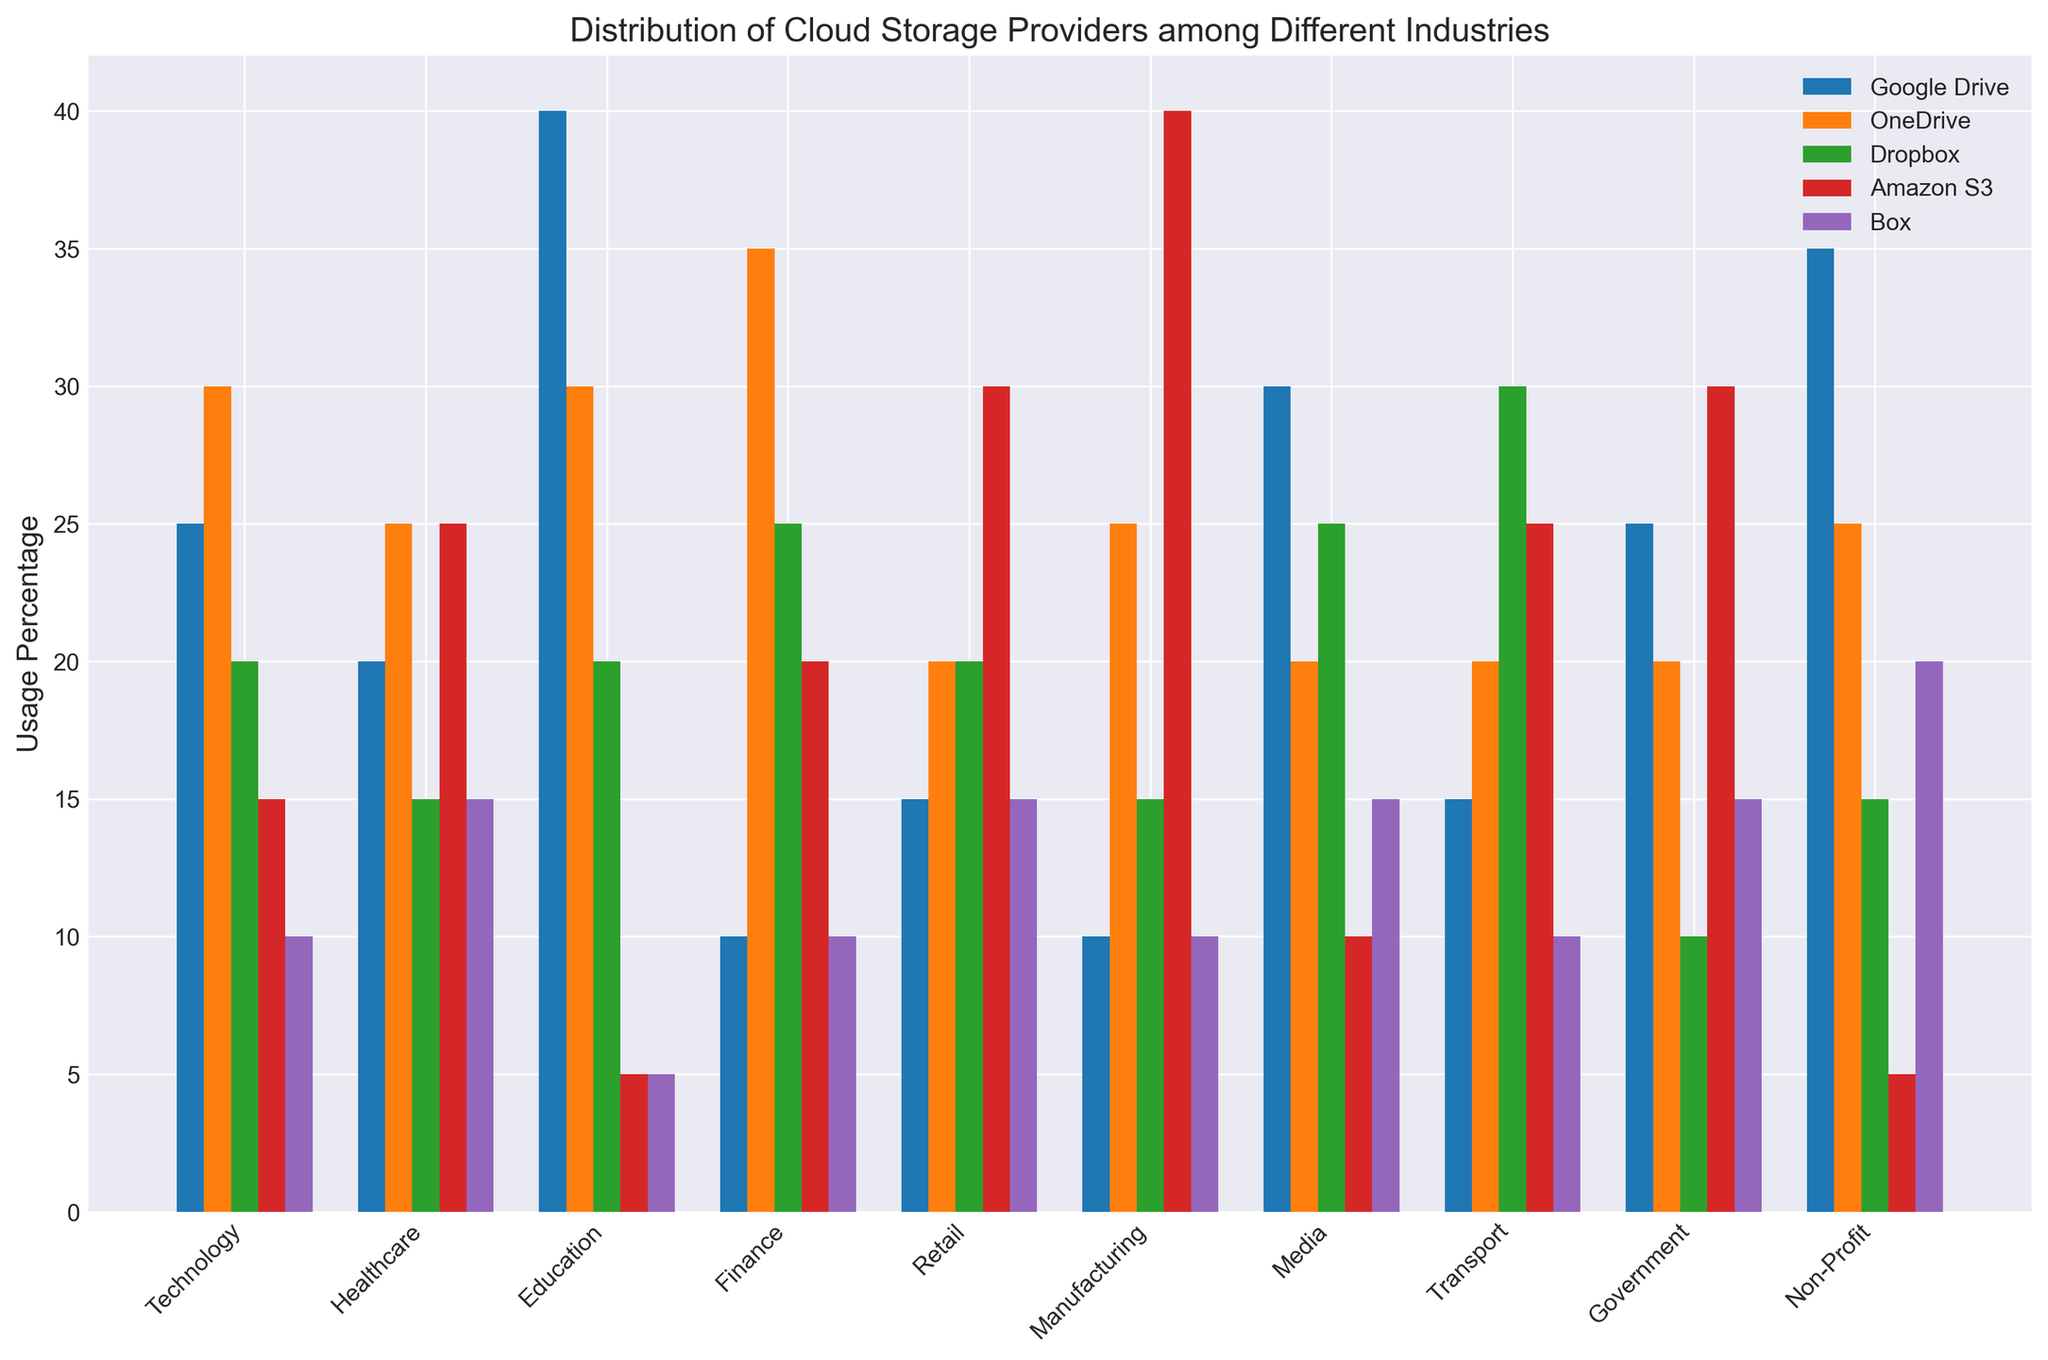Which industry has the highest percentage of Google Drive usage? By looking at the bar heights for Google Drive across all industries, it's clear the tallest bar belongs to the Education industry.
Answer: Education What is the total percentage of Amazon S3 usage across Technology, Healthcare, and Finance industries? Sum the percentages for Amazon S3 in Technology (15), Healthcare (25), and Finance (20). 15 + 25 + 20 = 60.
Answer: 60 Compare the usage of Box in the Government and Non-Profit industries. Which is higher? Check the bar heights for Box in both industries. Government has a usage percentage of 15%, while Non-Profit has 20%. So, Non-Profit is higher.
Answer: Non-Profit What’s the average usage percentage of Dropbox in the Retail, Manufacturing, and Media industries? Sum the percentages for Dropbox in Retail (20), Manufacturing (15), and Media (25), then divide by 3. (20 + 15 + 25) / 3 = 60 / 3 = 20.
Answer: 20 What is the difference in OneDrive usage between the Finance and Technology industries? Compare the OneDrive percentages for Finance (35) and Technology (30). The difference is 35 - 30 = 5.
Answer: 5 For the Transport industry, which cloud provider has the highest usage? Observing the bar heights for each cloud provider in the Transport category, Dropbox has the tallest bar at 30%.
Answer: Dropbox Which industry shows an equal usage percentage for Google Drive and Box? Look for industries where the Google Drive and Box bars are of equal height. The Education industry has equal bars at 5% each for both providers.
Answer: Education What is the combined usage percentage of OneDrive and Amazon S3 in the Media industry? Sum the usage percentages of OneDrive (20) and Amazon S3 (10) in the Media industry. 20 + 10 = 30.
Answer: 30 Among all industries, which provider is used the most in Manufacturing? By evaluating the bar heights for Manufacturing, Amazon S3 has the tallest bar at 40%.
Answer: Amazon S3 What is the median usage percentage of Google Drive across all industries? Listing the percentages for Google Drive in ascending order: 10, 10, 15, 15, 20, 25, 25, 30, 35, 40. The median is between the 5th and 6th values. (20 + 25) / 2 = 22.5.
Answer: 22.5 